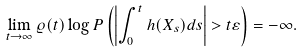Convert formula to latex. <formula><loc_0><loc_0><loc_500><loc_500>\lim _ { t \to \infty } \varrho ( t ) \log P \left ( \left | \int _ { 0 } ^ { t } h ( X _ { s } ) d s \right | > t \varepsilon \right ) = - \infty .</formula> 